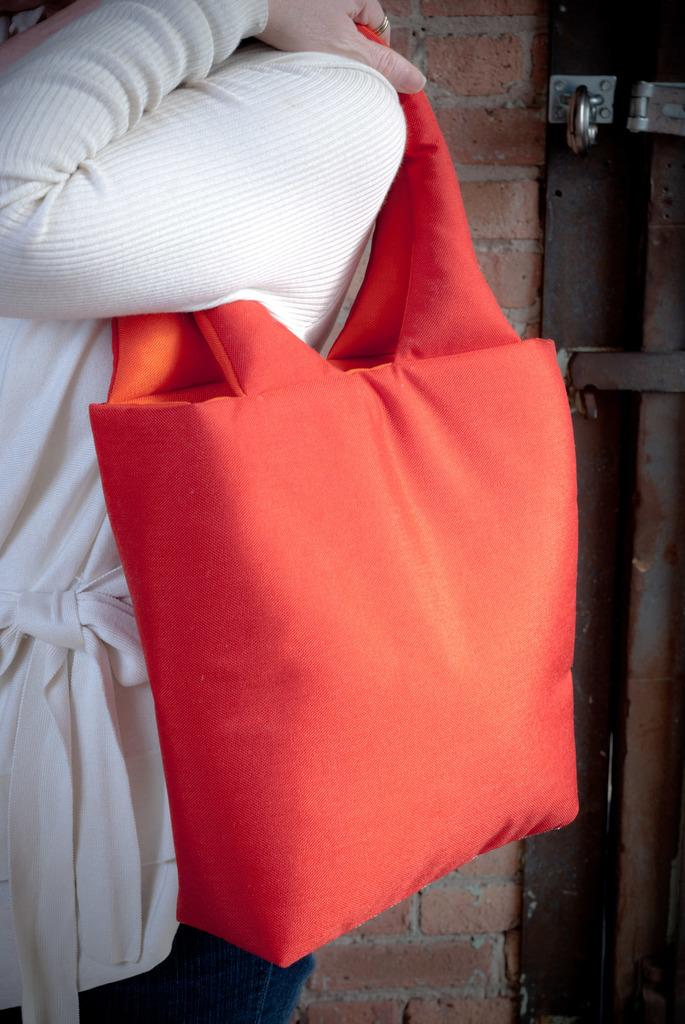What can be seen in the image? There is a person in the image. What is the person carrying? The person is carrying an orange bag. What is the person wearing on their upper body? The person is wearing a white top. What type of pants is the person wearing? The person is wearing blue jeans. What is visible behind the person? There is a wall behind the person. What type of collar can be seen on the person's shirt in the image? There is no collar visible on the person's shirt in the image, as they are wearing a white top. How many pies are visible on the wall behind the person? There are no pies present in the image; only a wall is visible behind the person. 